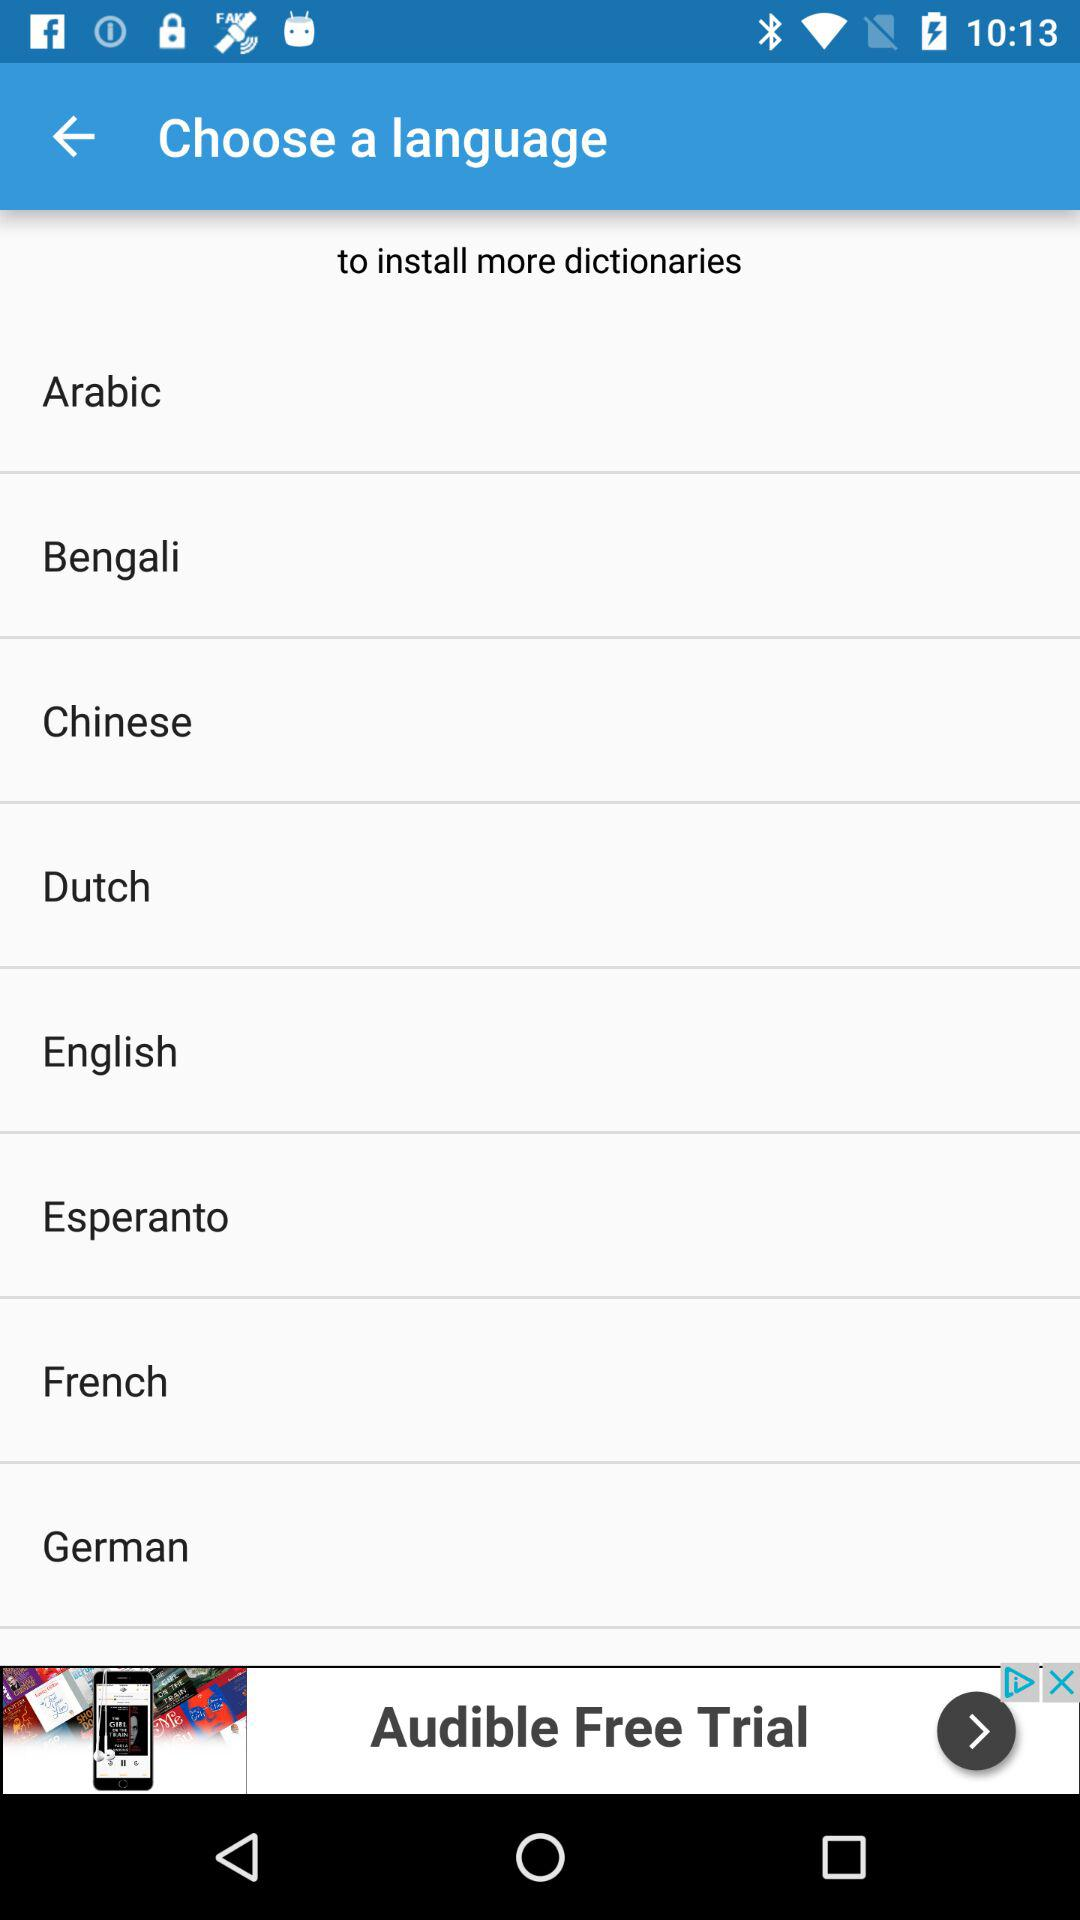How many languages are available to choose from?
Answer the question using a single word or phrase. 8 